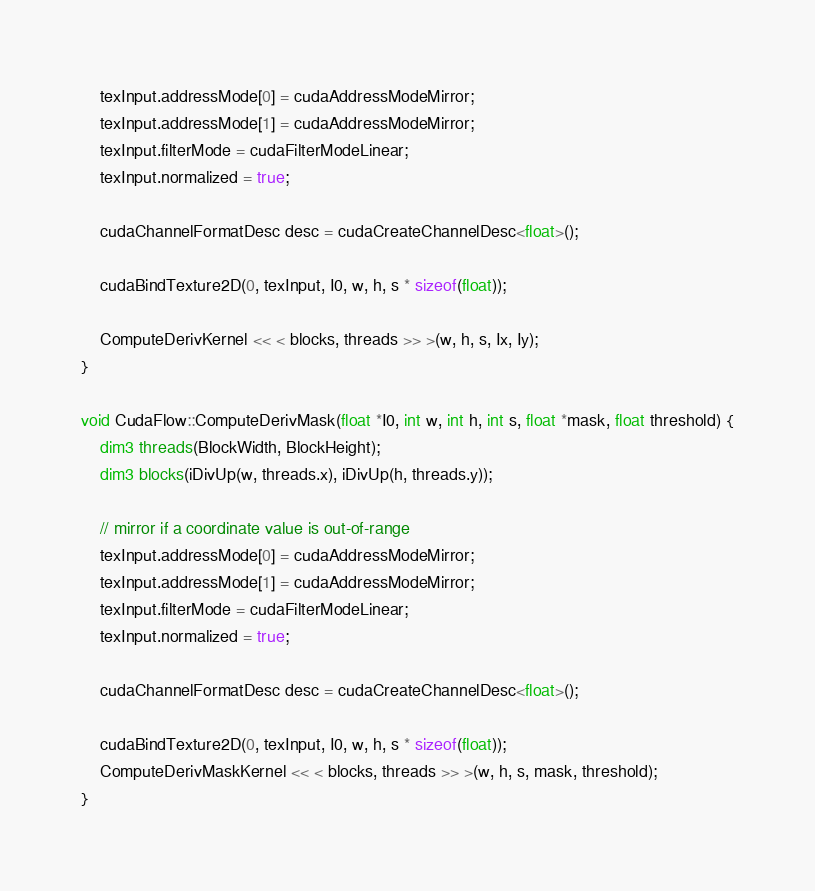Convert code to text. <code><loc_0><loc_0><loc_500><loc_500><_Cuda_>	texInput.addressMode[0] = cudaAddressModeMirror;
	texInput.addressMode[1] = cudaAddressModeMirror;
	texInput.filterMode = cudaFilterModeLinear;
	texInput.normalized = true;

	cudaChannelFormatDesc desc = cudaCreateChannelDesc<float>();

	cudaBindTexture2D(0, texInput, I0, w, h, s * sizeof(float));

	ComputeDerivKernel << < blocks, threads >> >(w, h, s, Ix, Iy);
}

void CudaFlow::ComputeDerivMask(float *I0, int w, int h, int s, float *mask, float threshold) {
	dim3 threads(BlockWidth, BlockHeight);
	dim3 blocks(iDivUp(w, threads.x), iDivUp(h, threads.y));

	// mirror if a coordinate value is out-of-range
	texInput.addressMode[0] = cudaAddressModeMirror;
	texInput.addressMode[1] = cudaAddressModeMirror;
	texInput.filterMode = cudaFilterModeLinear;
	texInput.normalized = true;

	cudaChannelFormatDesc desc = cudaCreateChannelDesc<float>();

	cudaBindTexture2D(0, texInput, I0, w, h, s * sizeof(float));
	ComputeDerivMaskKernel << < blocks, threads >> >(w, h, s, mask, threshold);
}
</code> 